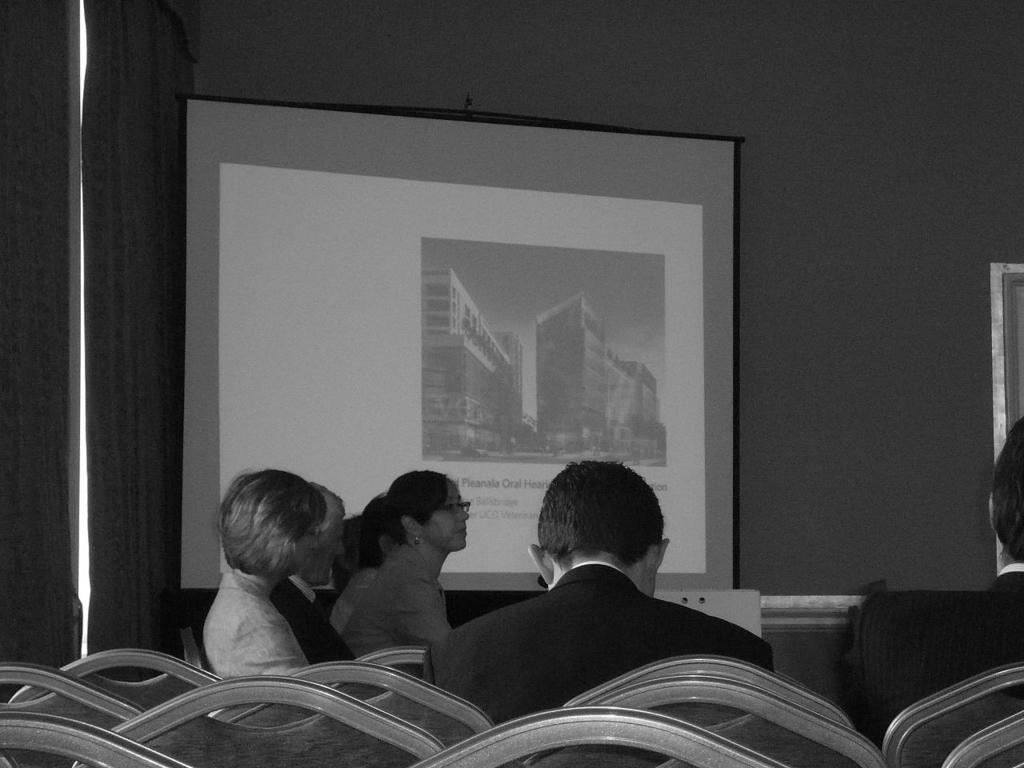What is the color scheme of the image? The image is black and white. What objects can be seen in the foreground of the image? There are chairs and people in the foreground of the image. What can be seen in the background of the image? There is a curtain, a projector screen, and a wall in the background of the image. How many clocks are visible on the wall in the image? There are no clocks visible on the wall in the image, as it is a black and white image with a curtain, projector screen, and wall in the background. Is there any visible dust on the chairs in the foreground of the image? The image is black and white, and there is no indication of dust on the chairs or any other objects in the image. 